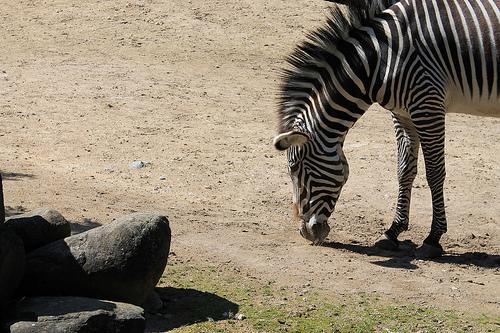Question: what pattern is the animal?
Choices:
A. Spotted.
B. Striped.
C. It has no pattern.
D. Zig zag lines.
Answer with the letter. Answer: B Question: what is on the zebra's head?
Choices:
A. A mane.
B. It's ears.
C. Stripes.
D. Mud.
Answer with the letter. Answer: A Question: when was this picture taken?
Choices:
A. During the day.
B. This afternoon.
C. In the dark.
D. This morning.
Answer with the letter. Answer: A Question: what animal is pictured?
Choices:
A. A lion.
B. A zebra.
C. A goat.
D. An elephant.
Answer with the letter. Answer: B Question: what is the zebra doing?
Choices:
A. Sleeping.
B. Running.
C. Drinking.
D. Eating.
Answer with the letter. Answer: D 